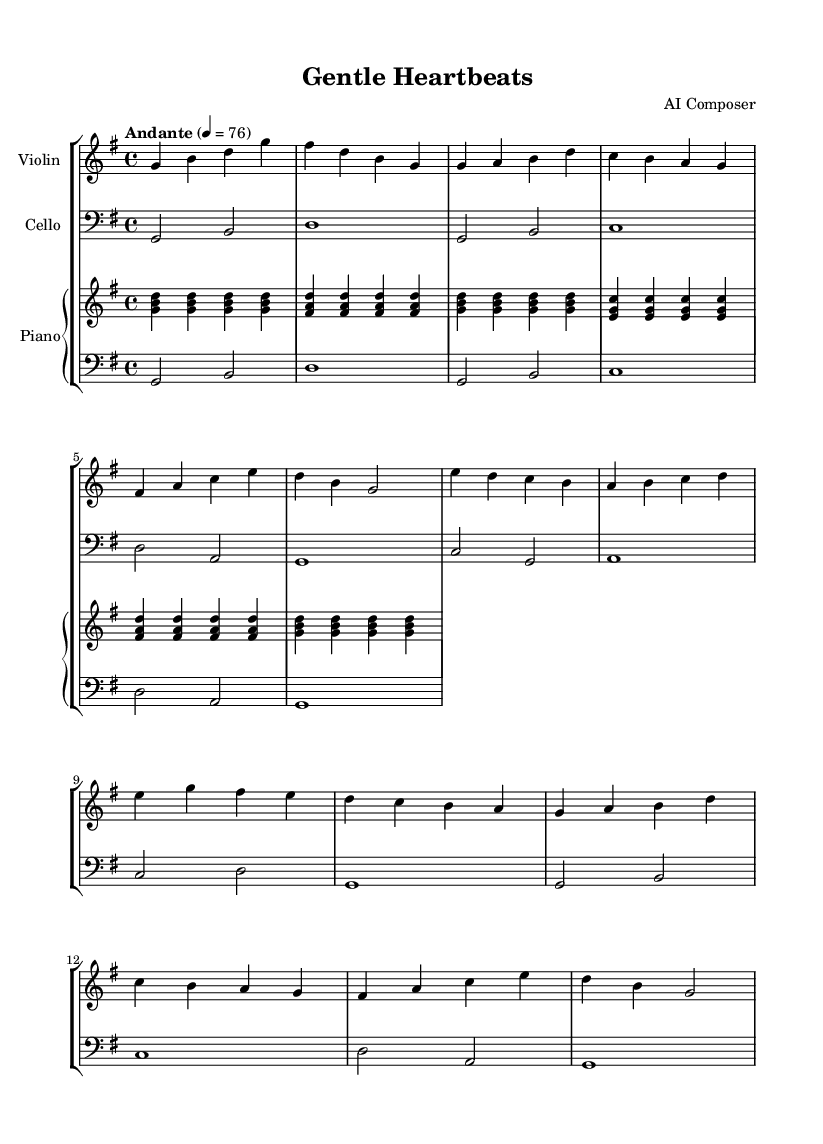What is the key signature of this music? The key signature shows one sharp, indicating the piece is in G major.
Answer: G major What is the time signature of this music? The time signature written at the beginning is 4/4, indicating four beats per measure.
Answer: 4/4 What is the tempo marking of the piece? The tempo marking indicates "Andante," suggesting a slow, walking pace at a speed of 76 beats per minute.
Answer: Andante What is the range of the violin part's highest note? The highest note in the violin part, as indicated by the notes, is d', which is the D note in the octave above middle C.
Answer: d' Which instruments are included in this piece? The score explicitly lists three instruments: Violin, Cello, and Piano.
Answer: Violin, Cello, Piano What is the dynamic marking for the cello part? The dynamic marking indicates "Down," suggesting that the cello plays with a softer sound or tone.
Answer: Down 